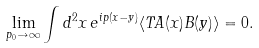<formula> <loc_0><loc_0><loc_500><loc_500>\lim _ { p _ { 0 } \to \infty } \int d ^ { 2 } x \, e ^ { i p ( x - y ) } \langle T A ( x ) B ( y ) \rangle = 0 .</formula> 